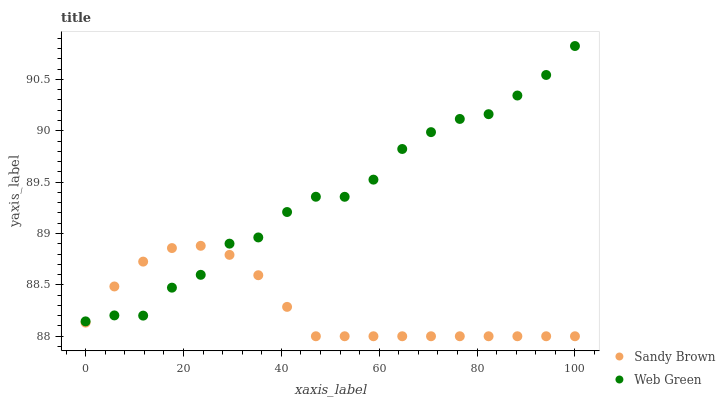Does Sandy Brown have the minimum area under the curve?
Answer yes or no. Yes. Does Web Green have the maximum area under the curve?
Answer yes or no. Yes. Does Web Green have the minimum area under the curve?
Answer yes or no. No. Is Sandy Brown the smoothest?
Answer yes or no. Yes. Is Web Green the roughest?
Answer yes or no. Yes. Is Web Green the smoothest?
Answer yes or no. No. Does Sandy Brown have the lowest value?
Answer yes or no. Yes. Does Web Green have the lowest value?
Answer yes or no. No. Does Web Green have the highest value?
Answer yes or no. Yes. Does Web Green intersect Sandy Brown?
Answer yes or no. Yes. Is Web Green less than Sandy Brown?
Answer yes or no. No. Is Web Green greater than Sandy Brown?
Answer yes or no. No. 